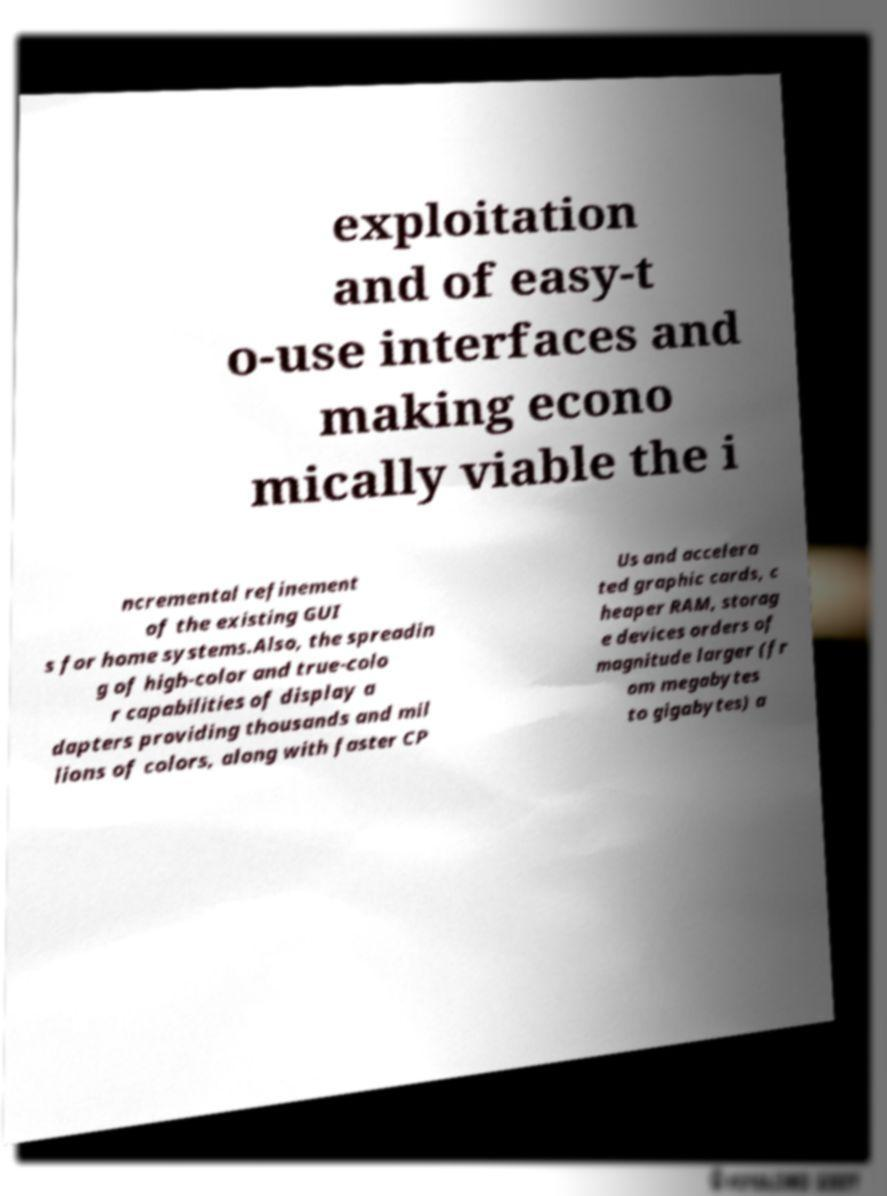Please identify and transcribe the text found in this image. exploitation and of easy-t o-use interfaces and making econo mically viable the i ncremental refinement of the existing GUI s for home systems.Also, the spreadin g of high-color and true-colo r capabilities of display a dapters providing thousands and mil lions of colors, along with faster CP Us and accelera ted graphic cards, c heaper RAM, storag e devices orders of magnitude larger (fr om megabytes to gigabytes) a 